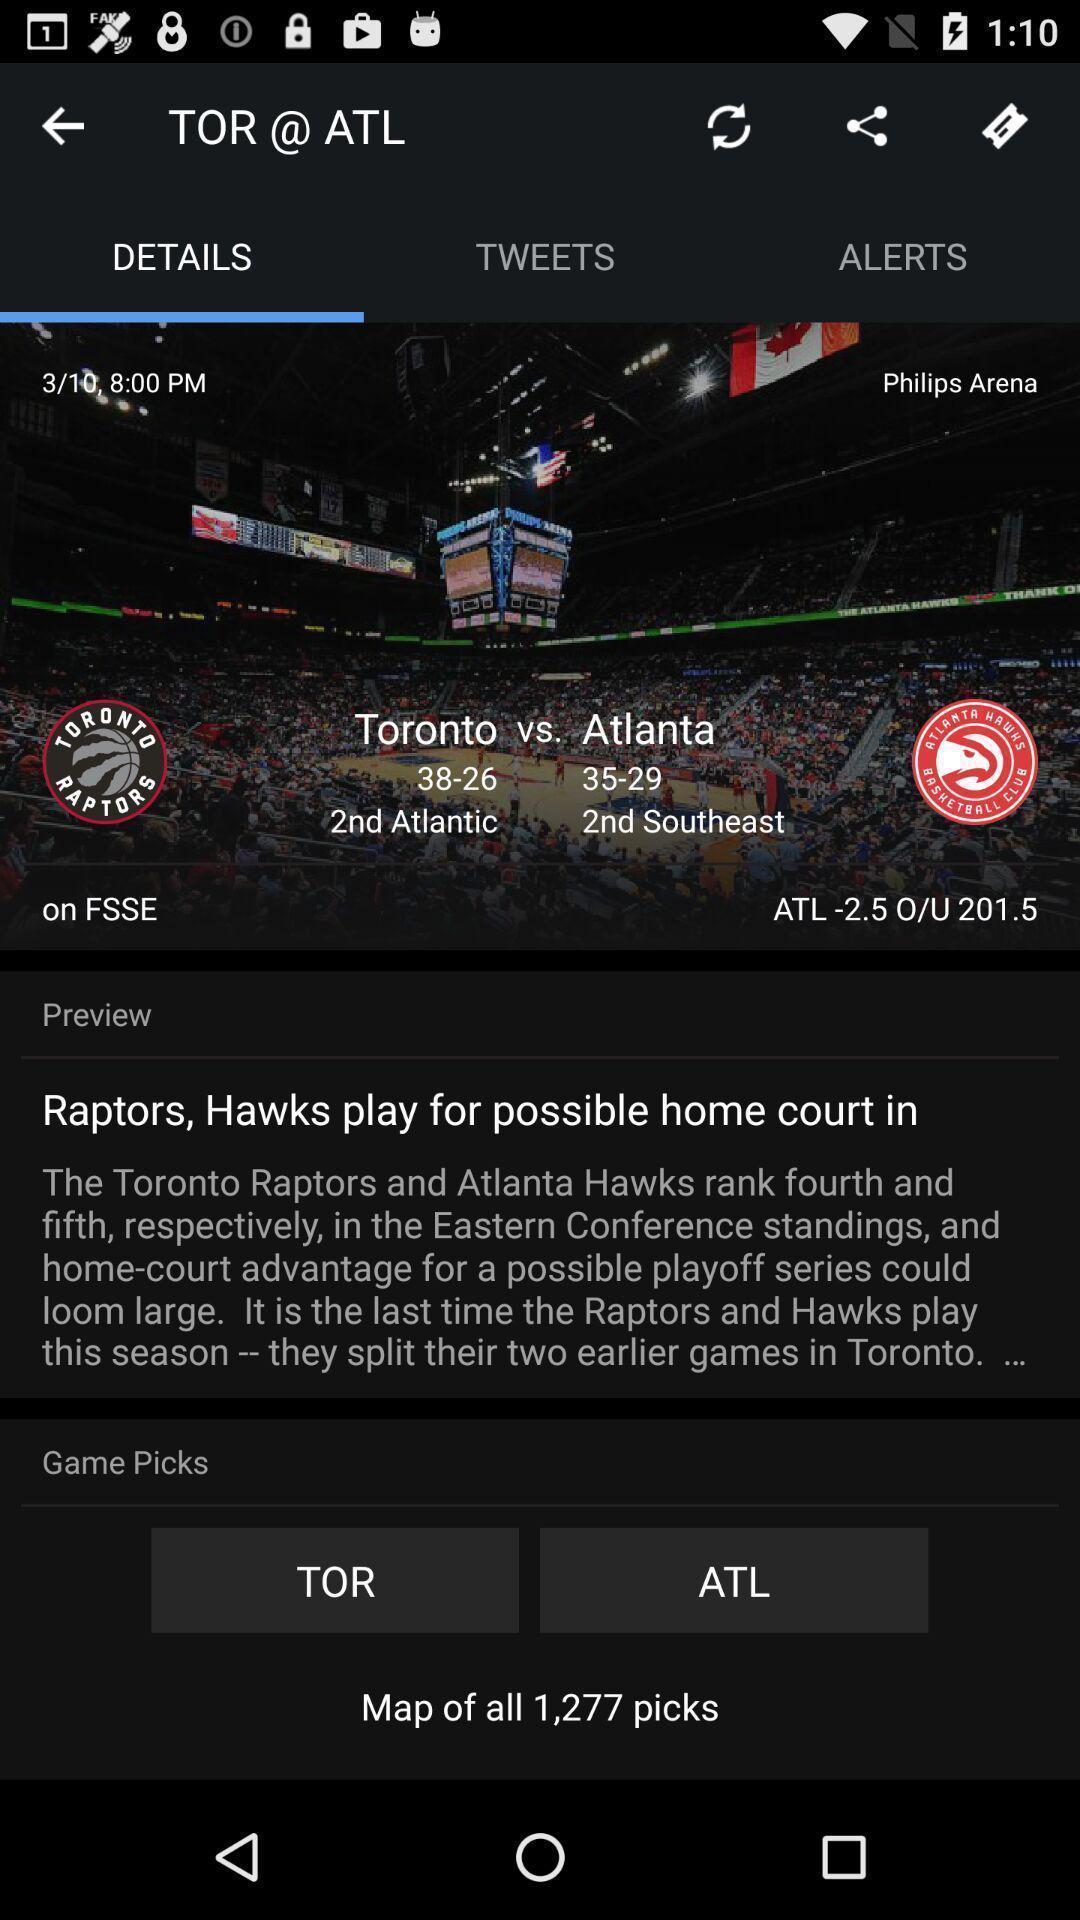Explain what's happening in this screen capture. Screen showing details of a sports game. 